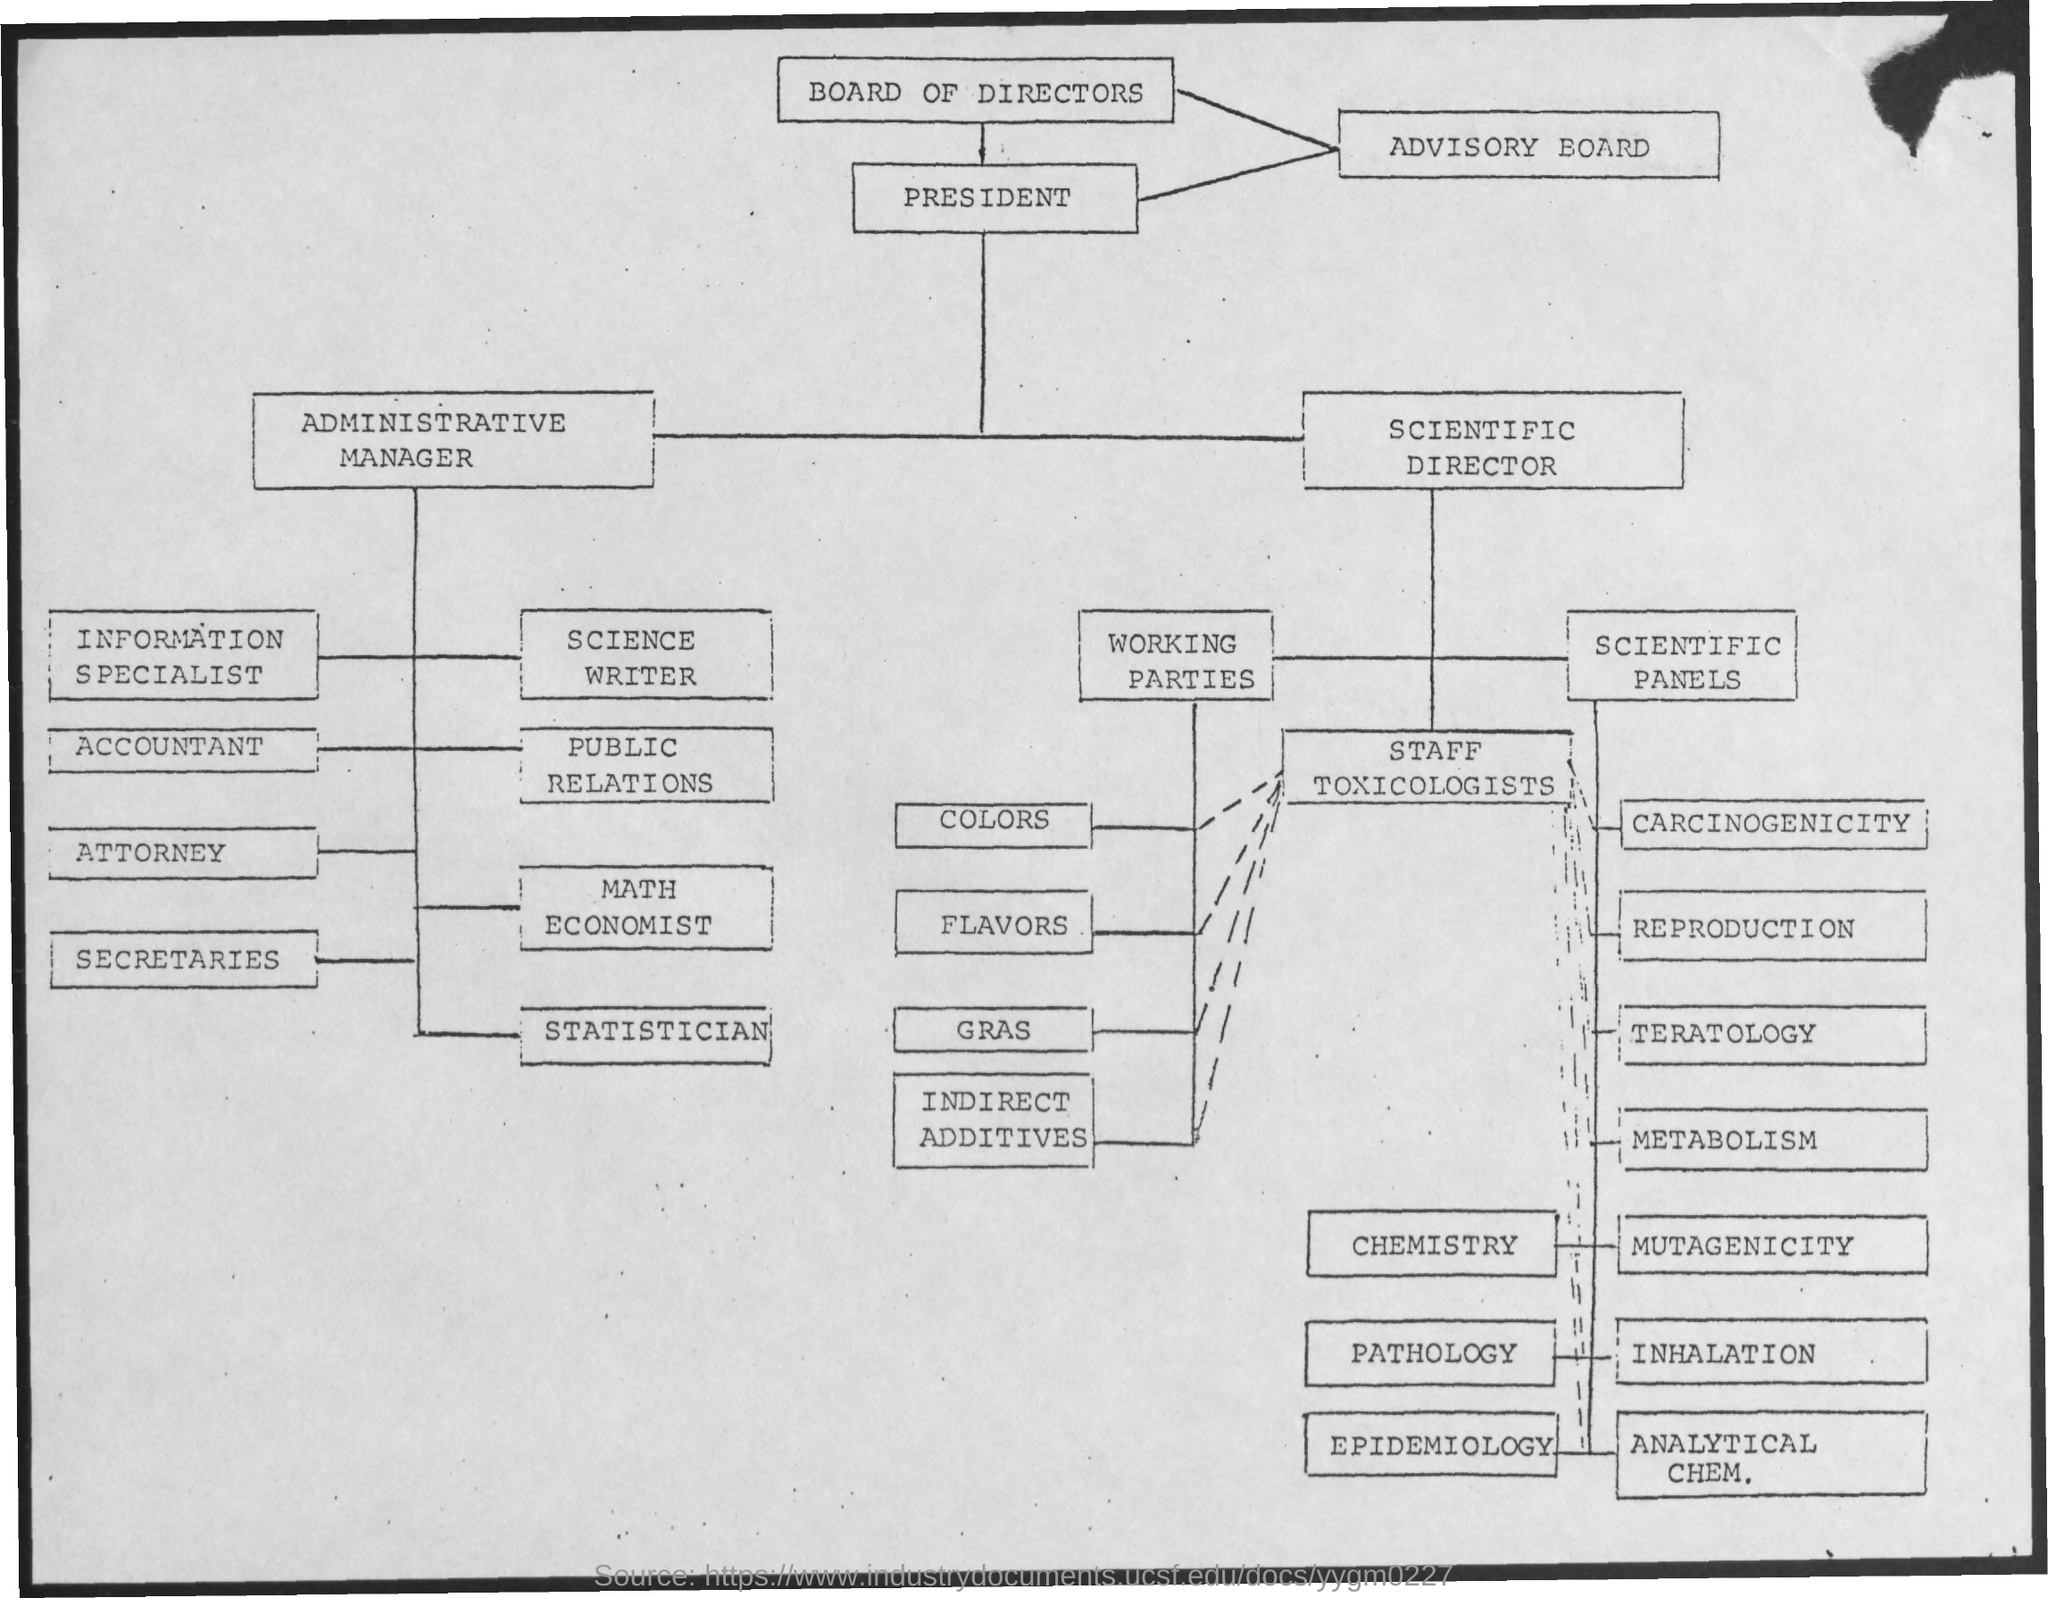Highlight a few significant elements in this photo. The text "Which text is in the first box? Board of Directors.." is in the first box. 